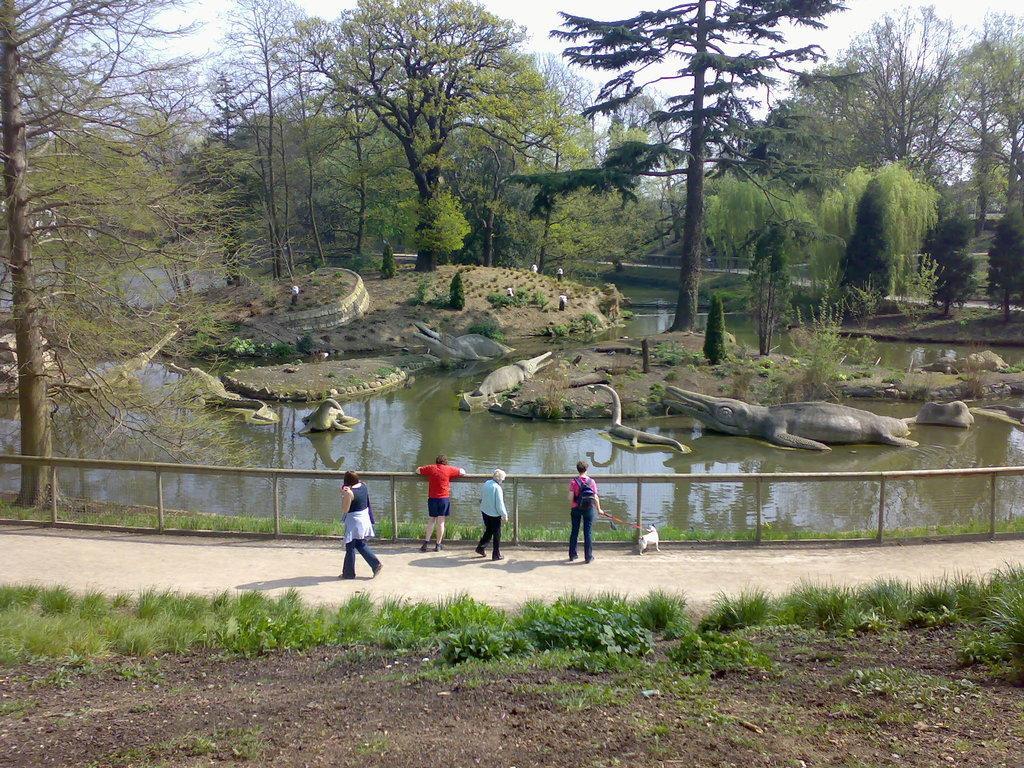How would you summarize this image in a sentence or two? This image is taken outdoors. At the bottom of the image there is a ground with grass on it. In the background there are many trees and plants on the ground. In the middle of the image there is a pond with water and there are a few plants on the ground and there are a few sculptures of crocodiles in the pond. A woman is walking on the road and three persons are standing on the road and there is a dog. There is a railing. 